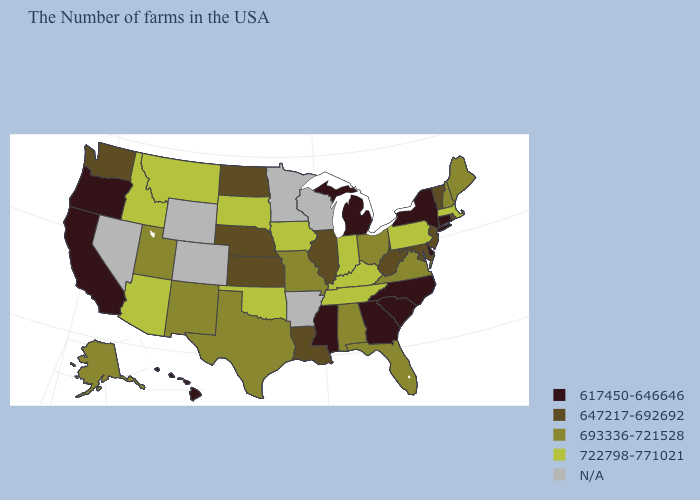What is the value of Maine?
Answer briefly. 693336-721528. Among the states that border North Carolina , which have the highest value?
Concise answer only. Tennessee. What is the value of California?
Quick response, please. 617450-646646. What is the highest value in the MidWest ?
Answer briefly. 722798-771021. Name the states that have a value in the range N/A?
Keep it brief. Wisconsin, Arkansas, Minnesota, Wyoming, Colorado, Nevada. Name the states that have a value in the range 693336-721528?
Write a very short answer. Maine, New Hampshire, Virginia, Ohio, Florida, Alabama, Missouri, Texas, New Mexico, Utah, Alaska. Which states have the lowest value in the USA?
Answer briefly. Connecticut, New York, Delaware, North Carolina, South Carolina, Georgia, Michigan, Mississippi, California, Oregon, Hawaii. What is the lowest value in the MidWest?
Be succinct. 617450-646646. Which states hav the highest value in the South?
Be succinct. Kentucky, Tennessee, Oklahoma. Name the states that have a value in the range 722798-771021?
Short answer required. Massachusetts, Pennsylvania, Kentucky, Indiana, Tennessee, Iowa, Oklahoma, South Dakota, Montana, Arizona, Idaho. What is the lowest value in the USA?
Short answer required. 617450-646646. Does New Hampshire have the lowest value in the Northeast?
Answer briefly. No. Which states have the lowest value in the West?
Give a very brief answer. California, Oregon, Hawaii. Name the states that have a value in the range 617450-646646?
Concise answer only. Connecticut, New York, Delaware, North Carolina, South Carolina, Georgia, Michigan, Mississippi, California, Oregon, Hawaii. What is the value of Mississippi?
Be succinct. 617450-646646. 